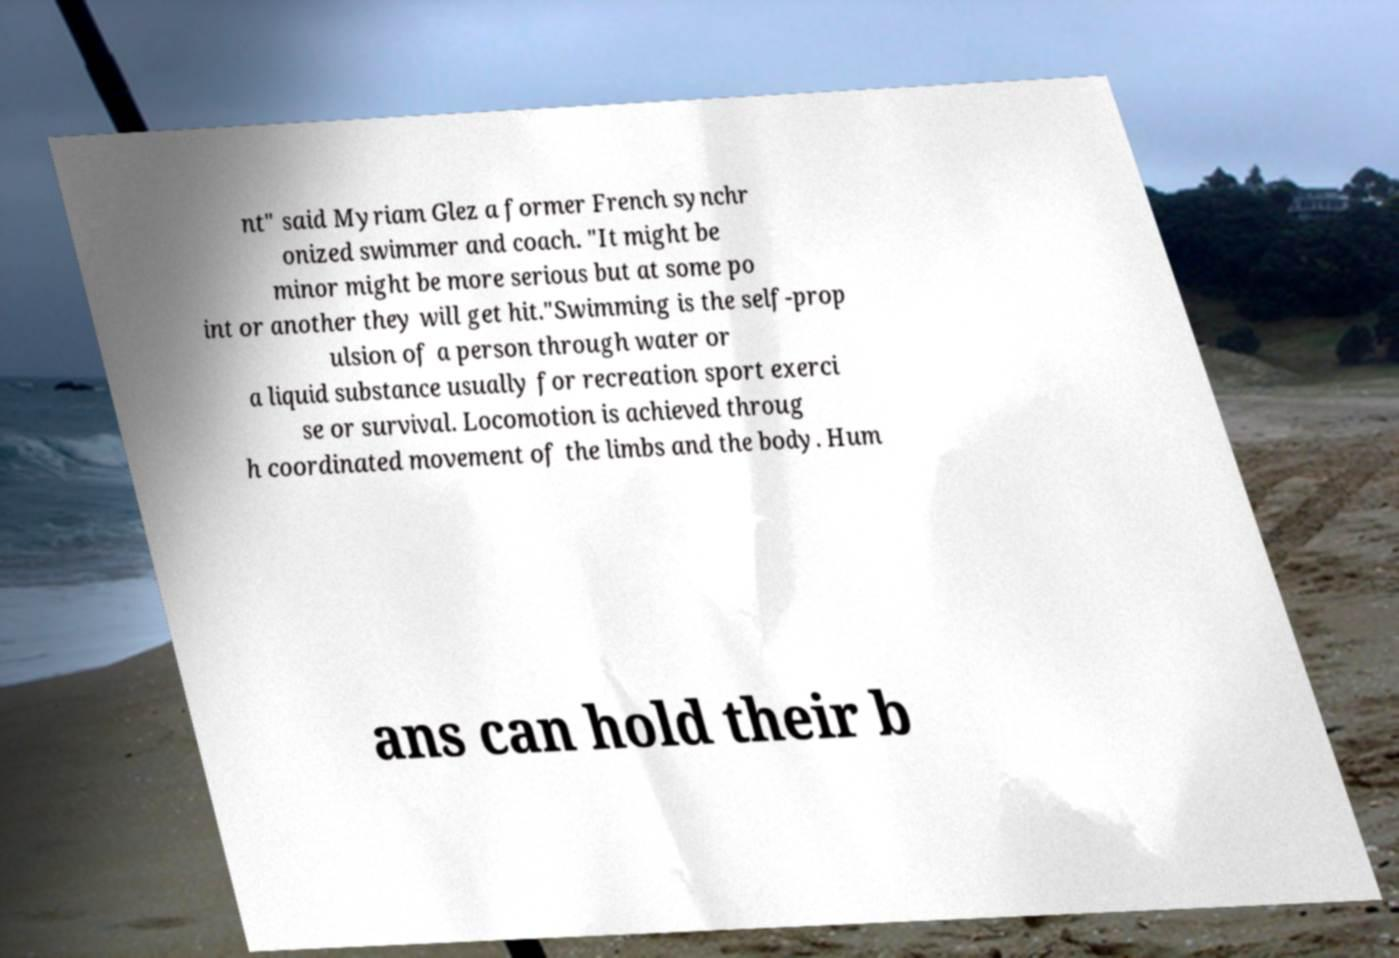Could you extract and type out the text from this image? nt" said Myriam Glez a former French synchr onized swimmer and coach. "It might be minor might be more serious but at some po int or another they will get hit."Swimming is the self-prop ulsion of a person through water or a liquid substance usually for recreation sport exerci se or survival. Locomotion is achieved throug h coordinated movement of the limbs and the body. Hum ans can hold their b 